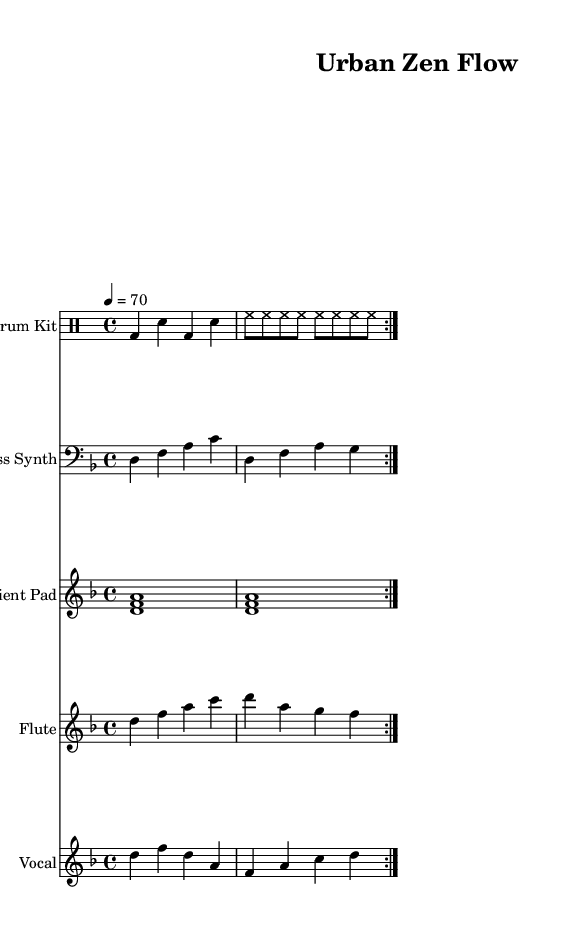What is the key signature of this music? The key signature is indicated at the beginning of the score. In this case, it shows two flats, indicating D minor as the key.
Answer: D minor What is the time signature of this piece? The time signature is typically found after the key signature. Here, we see a four over four notation, indicating that there are four beats in each measure and a quarter note gets one beat.
Answer: 4/4 What is the tempo marking for this composition? The tempo marking is located near the top of the score, indicating the speed of the piece. It states "4 = 70", meaning there are 70 beats per minute.
Answer: 70 How many times is the drum pattern repeated? The repeat markings are indicated within the drum part, showing a volta repeat section, which outlines that the pattern is played twice.
Answer: 2 What is the main lyrical content of the vocal part? The lyrics can be found below the vocal notes in the score. The line "Breathe in peace, breathe out stress" captures the essence of the piece's meditative quality.
Answer: Breathe in peace, breathe out stress Which instrument plays the ambient pad part? The specific instrument is labeled in the score, indicating that this part is designated for the "Ambient Pad". This is crucial for blending the music's meditative and urban elements.
Answer: Ambient Pad 